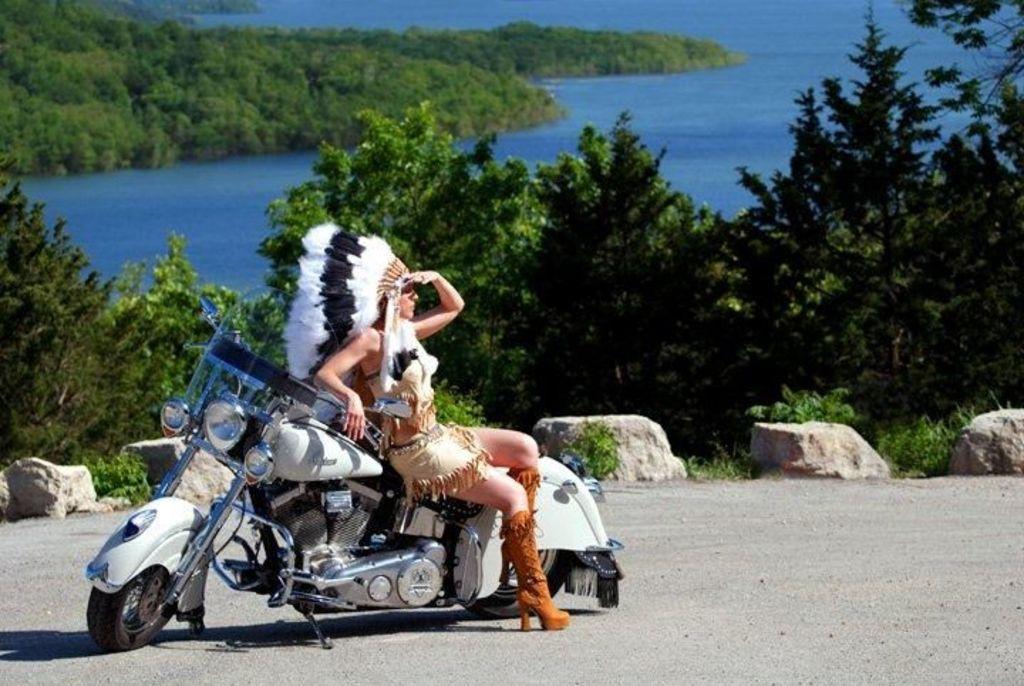How would you summarize this image in a sentence or two? In this image i can see a woman sitting on a bike at the background i can see a tree, a water. 